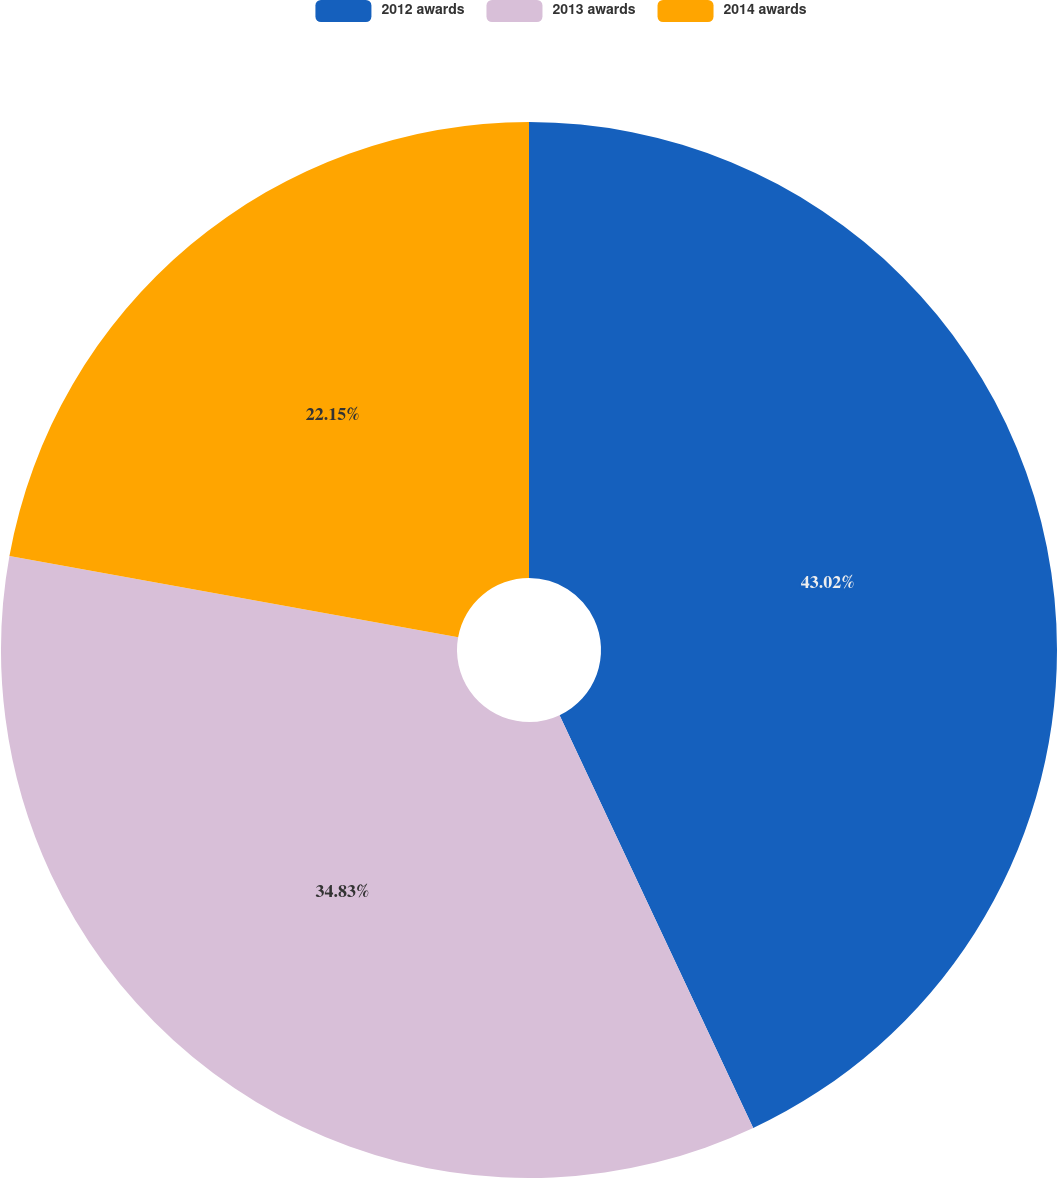Convert chart. <chart><loc_0><loc_0><loc_500><loc_500><pie_chart><fcel>2012 awards<fcel>2013 awards<fcel>2014 awards<nl><fcel>43.02%<fcel>34.83%<fcel>22.15%<nl></chart> 